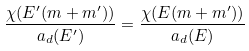Convert formula to latex. <formula><loc_0><loc_0><loc_500><loc_500>\frac { \chi ( E ^ { \prime } ( m + m ^ { \prime } ) ) } { a _ { d } ( E ^ { \prime } ) } = \frac { \chi ( E ( m + m ^ { \prime } ) ) } { a _ { d } ( E ) }</formula> 